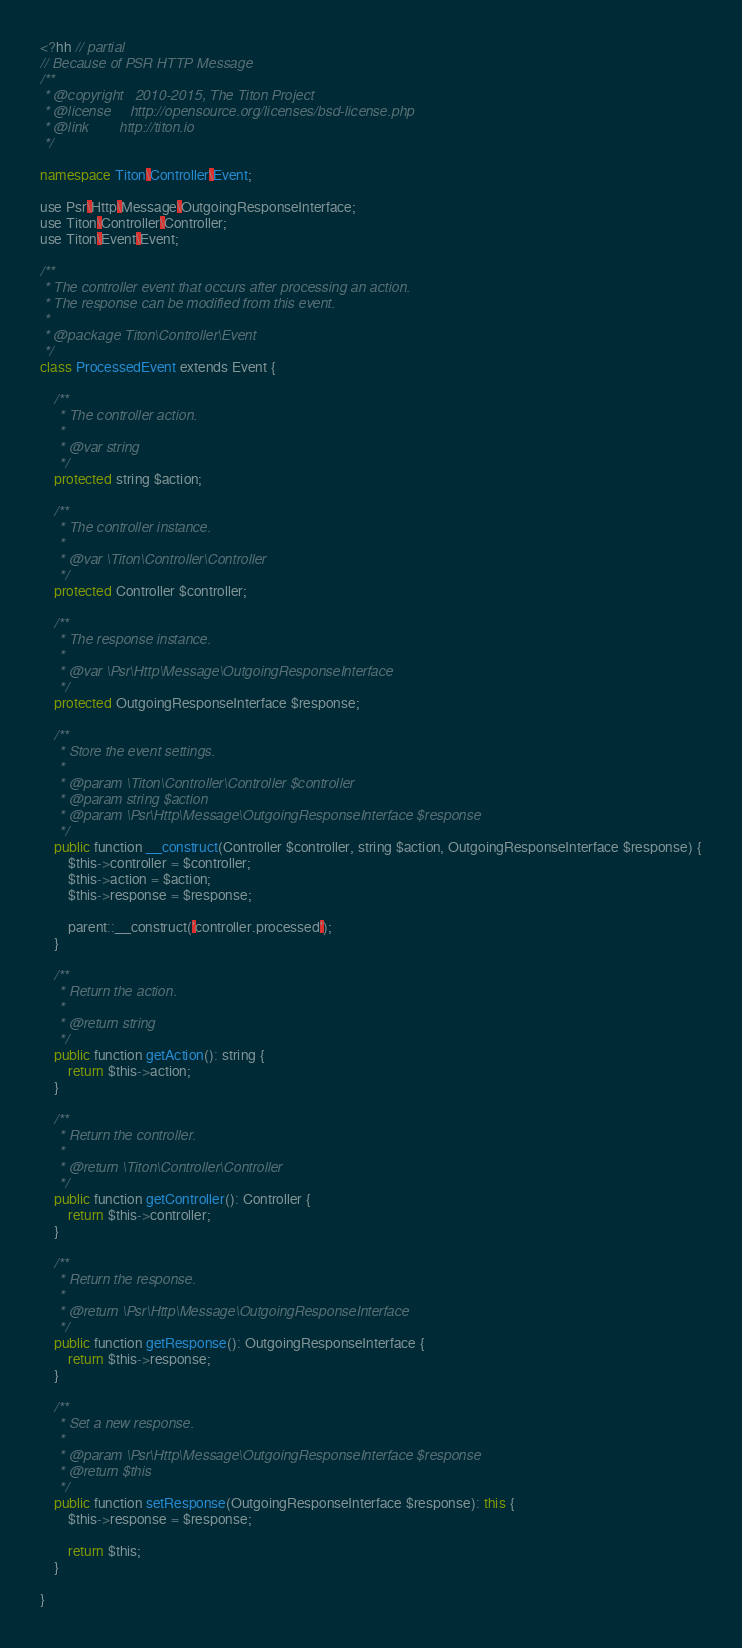<code> <loc_0><loc_0><loc_500><loc_500><_C++_><?hh // partial
// Because of PSR HTTP Message
/**
 * @copyright   2010-2015, The Titon Project
 * @license     http://opensource.org/licenses/bsd-license.php
 * @link        http://titon.io
 */

namespace Titon\Controller\Event;

use Psr\Http\Message\OutgoingResponseInterface;
use Titon\Controller\Controller;
use Titon\Event\Event;

/**
 * The controller event that occurs after processing an action.
 * The response can be modified from this event.
 *
 * @package Titon\Controller\Event
 */
class ProcessedEvent extends Event {

    /**
     * The controller action.
     *
     * @var string
     */
    protected string $action;

    /**
     * The controller instance.
     *
     * @var \Titon\Controller\Controller
     */
    protected Controller $controller;

    /**
     * The response instance.
     *
     * @var \Psr\Http\Message\OutgoingResponseInterface
     */
    protected OutgoingResponseInterface $response;

    /**
     * Store the event settings.
     *
     * @param \Titon\Controller\Controller $controller
     * @param string $action
     * @param \Psr\Http\Message\OutgoingResponseInterface $response
     */
    public function __construct(Controller $controller, string $action, OutgoingResponseInterface $response) {
        $this->controller = $controller;
        $this->action = $action;
        $this->response = $response;

        parent::__construct('controller.processed');
    }

    /**
     * Return the action.
     *
     * @return string
     */
    public function getAction(): string {
        return $this->action;
    }

    /**
     * Return the controller.
     *
     * @return \Titon\Controller\Controller
     */
    public function getController(): Controller {
        return $this->controller;
    }

    /**
     * Return the response.
     *
     * @return \Psr\Http\Message\OutgoingResponseInterface
     */
    public function getResponse(): OutgoingResponseInterface {
        return $this->response;
    }

    /**
     * Set a new response.
     *
     * @param \Psr\Http\Message\OutgoingResponseInterface $response
     * @return $this
     */
    public function setResponse(OutgoingResponseInterface $response): this {
        $this->response = $response;

        return $this;
    }

}
</code> 